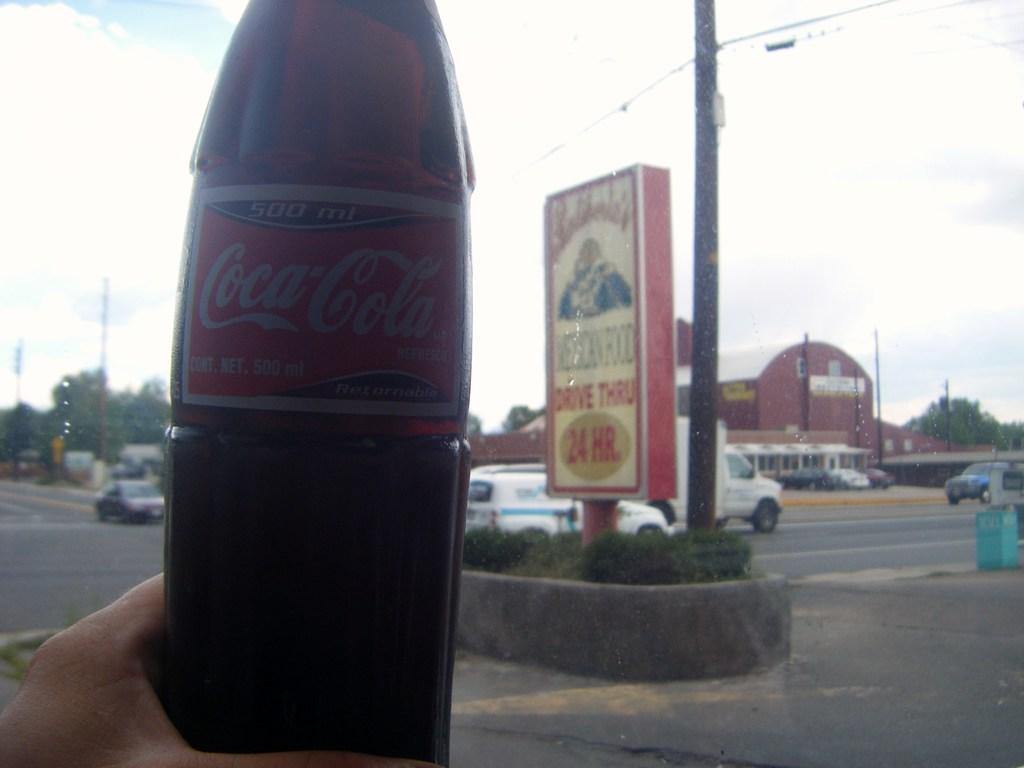<image>
Create a compact narrative representing the image presented. Person holding a glass bottle of a Coca Cola. 